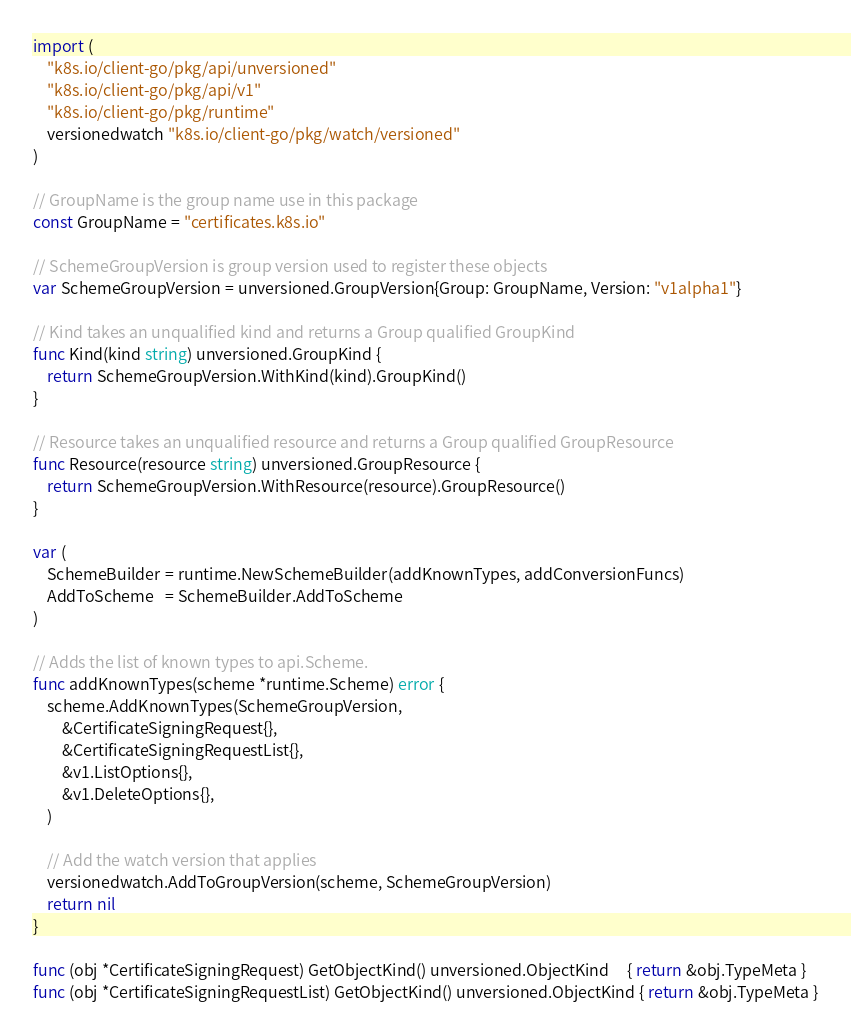Convert code to text. <code><loc_0><loc_0><loc_500><loc_500><_Go_>
import (
	"k8s.io/client-go/pkg/api/unversioned"
	"k8s.io/client-go/pkg/api/v1"
	"k8s.io/client-go/pkg/runtime"
	versionedwatch "k8s.io/client-go/pkg/watch/versioned"
)

// GroupName is the group name use in this package
const GroupName = "certificates.k8s.io"

// SchemeGroupVersion is group version used to register these objects
var SchemeGroupVersion = unversioned.GroupVersion{Group: GroupName, Version: "v1alpha1"}

// Kind takes an unqualified kind and returns a Group qualified GroupKind
func Kind(kind string) unversioned.GroupKind {
	return SchemeGroupVersion.WithKind(kind).GroupKind()
}

// Resource takes an unqualified resource and returns a Group qualified GroupResource
func Resource(resource string) unversioned.GroupResource {
	return SchemeGroupVersion.WithResource(resource).GroupResource()
}

var (
	SchemeBuilder = runtime.NewSchemeBuilder(addKnownTypes, addConversionFuncs)
	AddToScheme   = SchemeBuilder.AddToScheme
)

// Adds the list of known types to api.Scheme.
func addKnownTypes(scheme *runtime.Scheme) error {
	scheme.AddKnownTypes(SchemeGroupVersion,
		&CertificateSigningRequest{},
		&CertificateSigningRequestList{},
		&v1.ListOptions{},
		&v1.DeleteOptions{},
	)

	// Add the watch version that applies
	versionedwatch.AddToGroupVersion(scheme, SchemeGroupVersion)
	return nil
}

func (obj *CertificateSigningRequest) GetObjectKind() unversioned.ObjectKind     { return &obj.TypeMeta }
func (obj *CertificateSigningRequestList) GetObjectKind() unversioned.ObjectKind { return &obj.TypeMeta }
</code> 